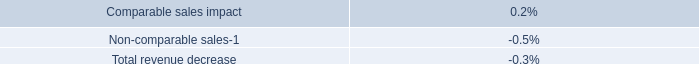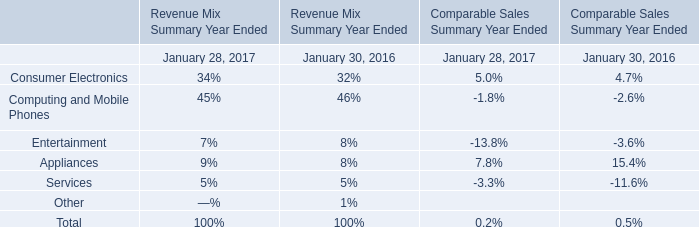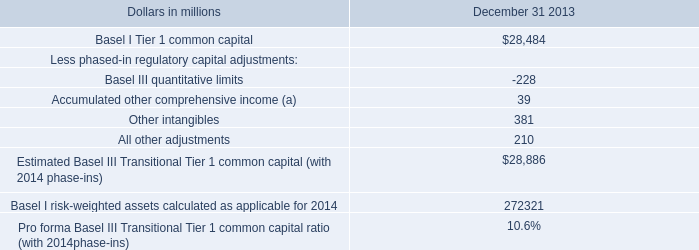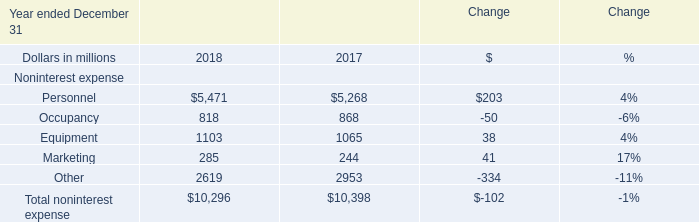What is the sum of Basel I Tier 1 common capital of December 31 2013, Equipment of Change 2018, and Total noninterest expense of Change 2017 ? 
Computations: ((28484.0 + 1103.0) + 10398.0)
Answer: 39985.0. 